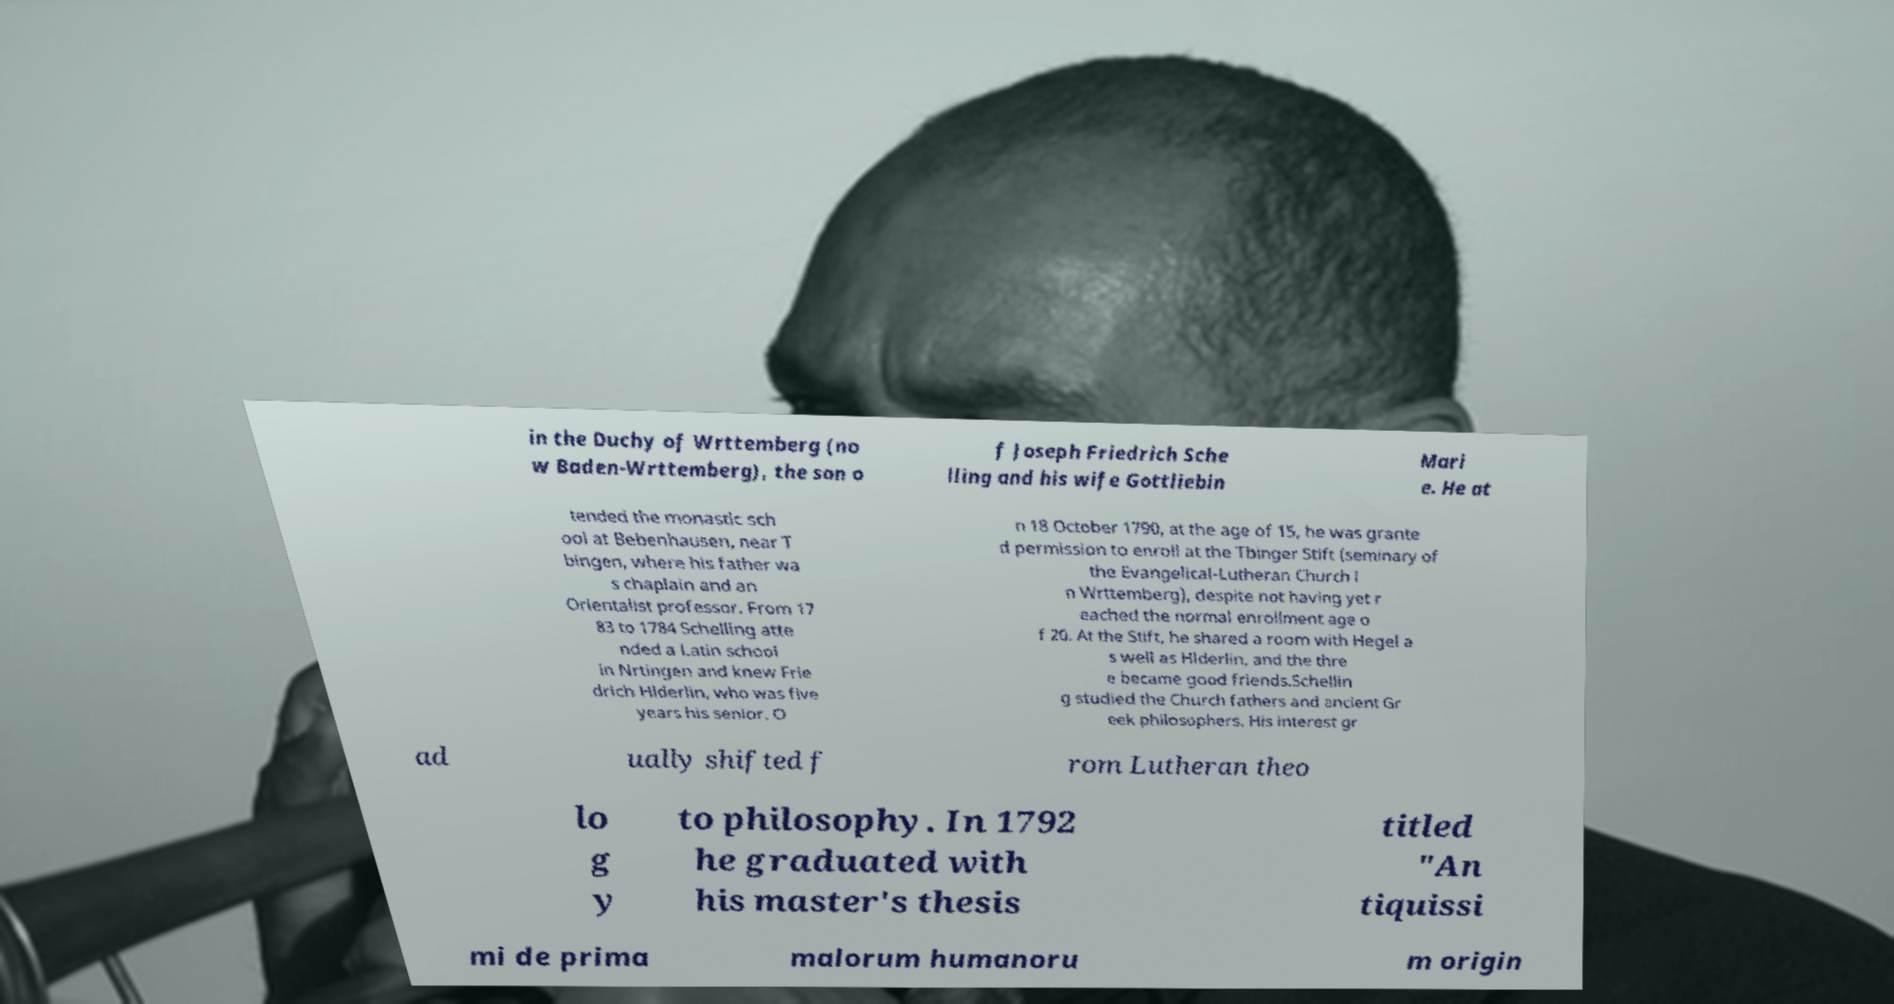Can you accurately transcribe the text from the provided image for me? in the Duchy of Wrttemberg (no w Baden-Wrttemberg), the son o f Joseph Friedrich Sche lling and his wife Gottliebin Mari e. He at tended the monastic sch ool at Bebenhausen, near T bingen, where his father wa s chaplain and an Orientalist professor. From 17 83 to 1784 Schelling atte nded a Latin school in Nrtingen and knew Frie drich Hlderlin, who was five years his senior. O n 18 October 1790, at the age of 15, he was grante d permission to enroll at the Tbinger Stift (seminary of the Evangelical-Lutheran Church i n Wrttemberg), despite not having yet r eached the normal enrollment age o f 20. At the Stift, he shared a room with Hegel a s well as Hlderlin, and the thre e became good friends.Schellin g studied the Church fathers and ancient Gr eek philosophers. His interest gr ad ually shifted f rom Lutheran theo lo g y to philosophy. In 1792 he graduated with his master's thesis titled "An tiquissi mi de prima malorum humanoru m origin 